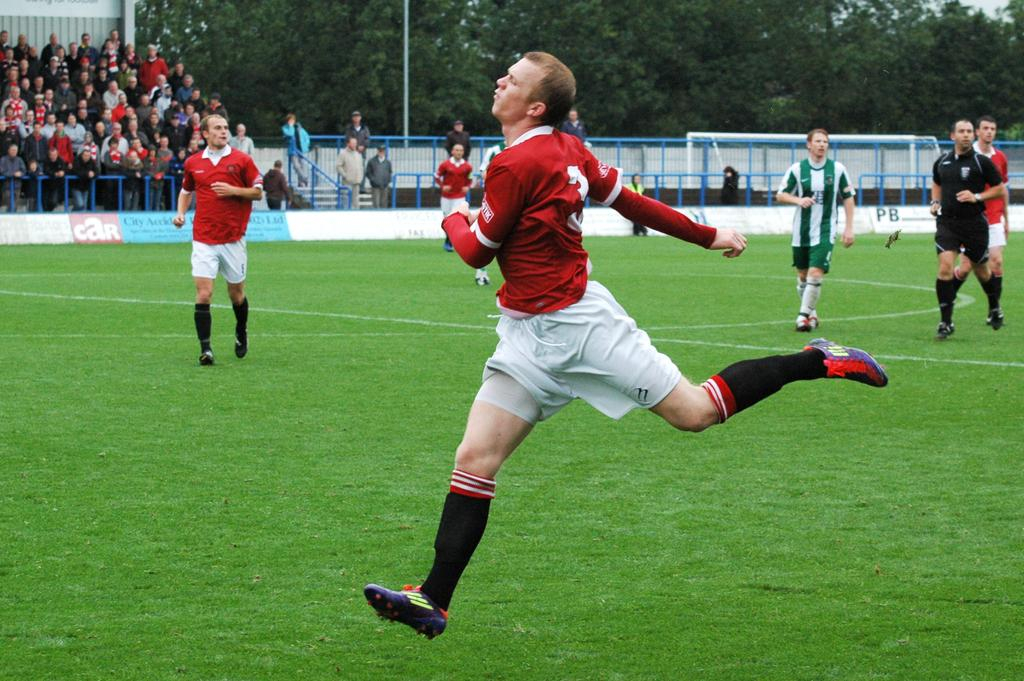What are the people in the image doing? The people in the image are running on the ground. What can be seen in the background of the image? In the background, there are railings, trees, a pole, a crowd, and a wall. Can you describe the setting of the image? The image appears to be set in an outdoor area with a crowd and various structures in the background. What arithmetic problem is being solved by the boys in the image? There are no boys or arithmetic problems present in the image; it features people running and various background elements. What sign can be seen directing the runners in the image? There is no sign visible in the image; it only shows people running and the background elements. 